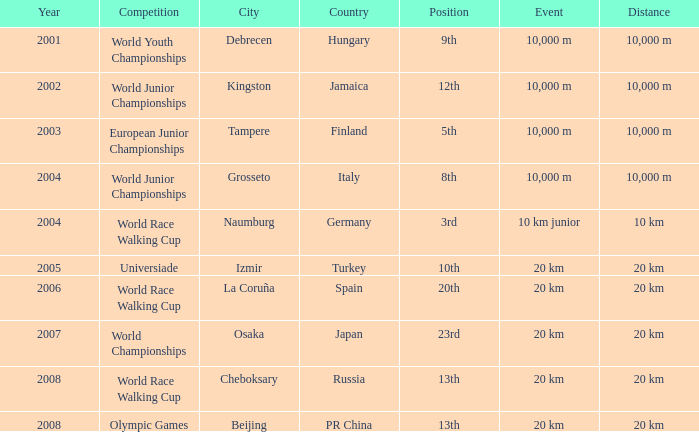In which venue did he place 3rd in the World Race Walking Cup? Naumburg , Germany. 